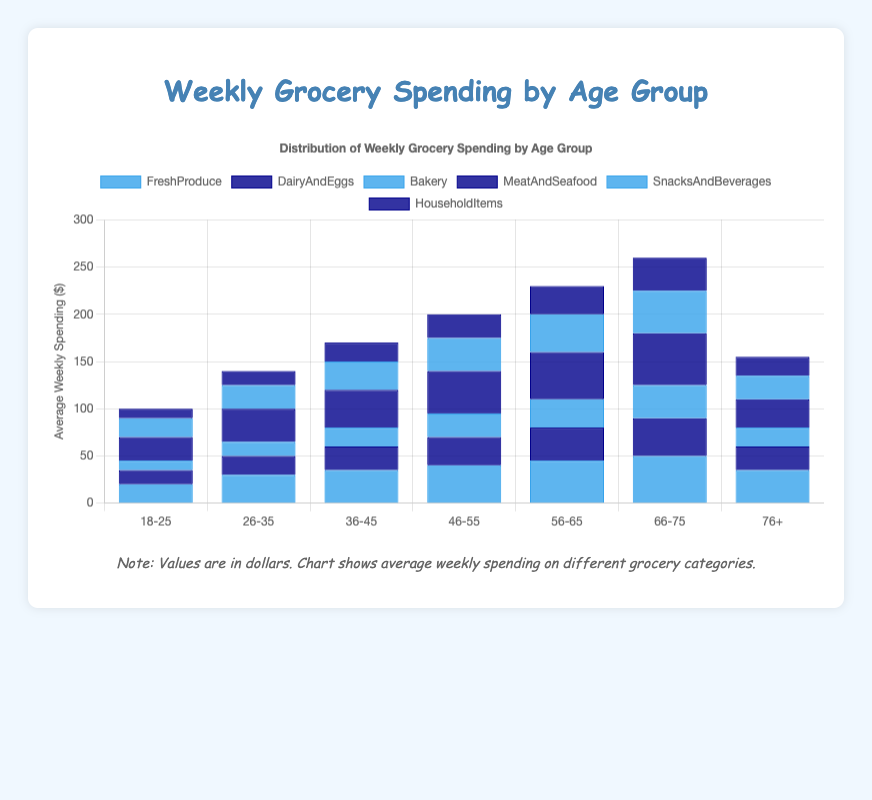What is the average weekly spending on Fresh Produce for the 56-65 and 66-75 age groups combined? The average for 56-65 is 45, and for 66-75 is 50. The combined average is (45 + 50) / 2 = 47.5
Answer: 47.5 Which age group spends the most on Meat and Seafood? By examining the height of the blue and dark blue bars representing Meat and Seafood among the age groups, the highest spending is in the 66-75 age group at 55 dollars.
Answer: 66-75 Between the 18-25 and 76+ age groups, which one spends more on Snacks and Beverages? The 18-25 age group spends 20 dollars, while the 76+ age group spends 25 dollars on Snacks and Beverages. So, the 76+ age group spends more.
Answer: 76+ What is the total weekly spending across all categories for the 46-55 age group? Sum of spending for 46-55 is FreshProduce (40) + DairyAndEggs (30) + Bakery (25) + MeatAndSeafood (45) + SnacksAndBeverages (35) + HouseholdItems (25), which totals to 40 + 30 + 25 + 45 + 35 + 25 = 200.
Answer: 200 How much more does the 26-35 age group spend on Fresh Produce compared to the 18-25 age group? The 26-35 age group spends 30 dollars on Fresh Produce, while the 18-25 age group spends 20 dollars. The difference is 30 - 20 = 10.
Answer: 10 Which age group has the lowest average weekly spending on Bakery? By examining the heights of the bars representing Bakery spending, the 18-25 age group spends the least at 10 dollars.
Answer: 18-25 Do the 36-45 and 56-65 age groups spend the same amount on Dairy and Eggs? Comparing the heights of the blue and dark blue bars for Dairy and Eggs, the 36-45 age group spends 25 dollars, while the 56-65 age group spends 35 dollars, so they do not spend the same amount.
Answer: No How much does the 76+ age group spend less on Meat and Seafood compared to the 66-75 age group? The 66-75 age group spends 55 dollars, while the 76+ age group spends 30 dollars. The difference is 55 - 30 = 25.
Answer: 25 